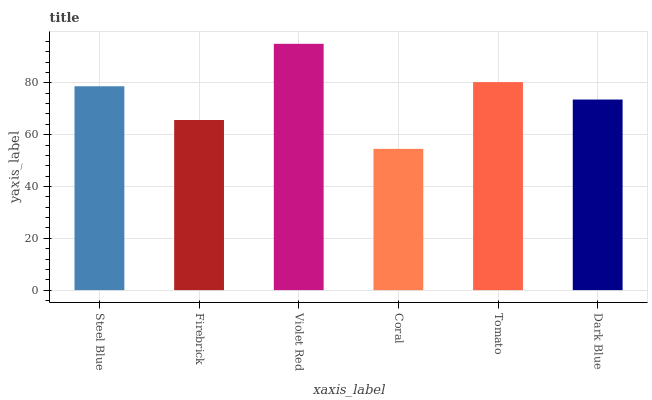Is Coral the minimum?
Answer yes or no. Yes. Is Violet Red the maximum?
Answer yes or no. Yes. Is Firebrick the minimum?
Answer yes or no. No. Is Firebrick the maximum?
Answer yes or no. No. Is Steel Blue greater than Firebrick?
Answer yes or no. Yes. Is Firebrick less than Steel Blue?
Answer yes or no. Yes. Is Firebrick greater than Steel Blue?
Answer yes or no. No. Is Steel Blue less than Firebrick?
Answer yes or no. No. Is Steel Blue the high median?
Answer yes or no. Yes. Is Dark Blue the low median?
Answer yes or no. Yes. Is Firebrick the high median?
Answer yes or no. No. Is Firebrick the low median?
Answer yes or no. No. 